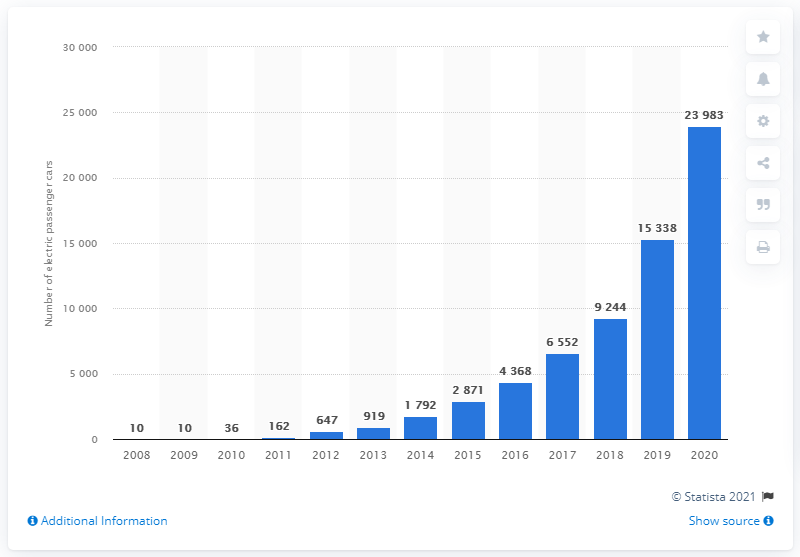Point out several critical features in this image. In 2008, electric vehicles saw a significant increase in emissions. 